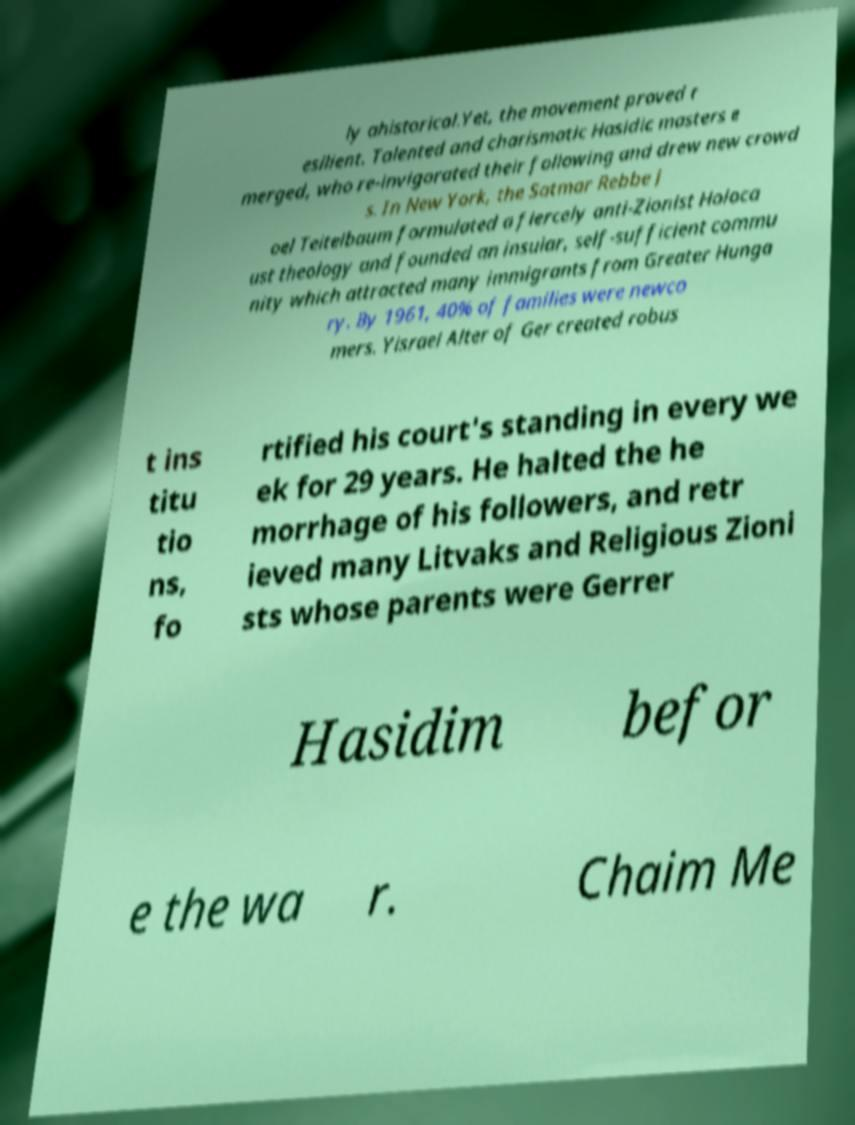There's text embedded in this image that I need extracted. Can you transcribe it verbatim? ly ahistorical.Yet, the movement proved r esilient. Talented and charismatic Hasidic masters e merged, who re-invigorated their following and drew new crowd s. In New York, the Satmar Rebbe J oel Teitelbaum formulated a fiercely anti-Zionist Holoca ust theology and founded an insular, self-sufficient commu nity which attracted many immigrants from Greater Hunga ry. By 1961, 40% of families were newco mers. Yisrael Alter of Ger created robus t ins titu tio ns, fo rtified his court's standing in every we ek for 29 years. He halted the he morrhage of his followers, and retr ieved many Litvaks and Religious Zioni sts whose parents were Gerrer Hasidim befor e the wa r. Chaim Me 